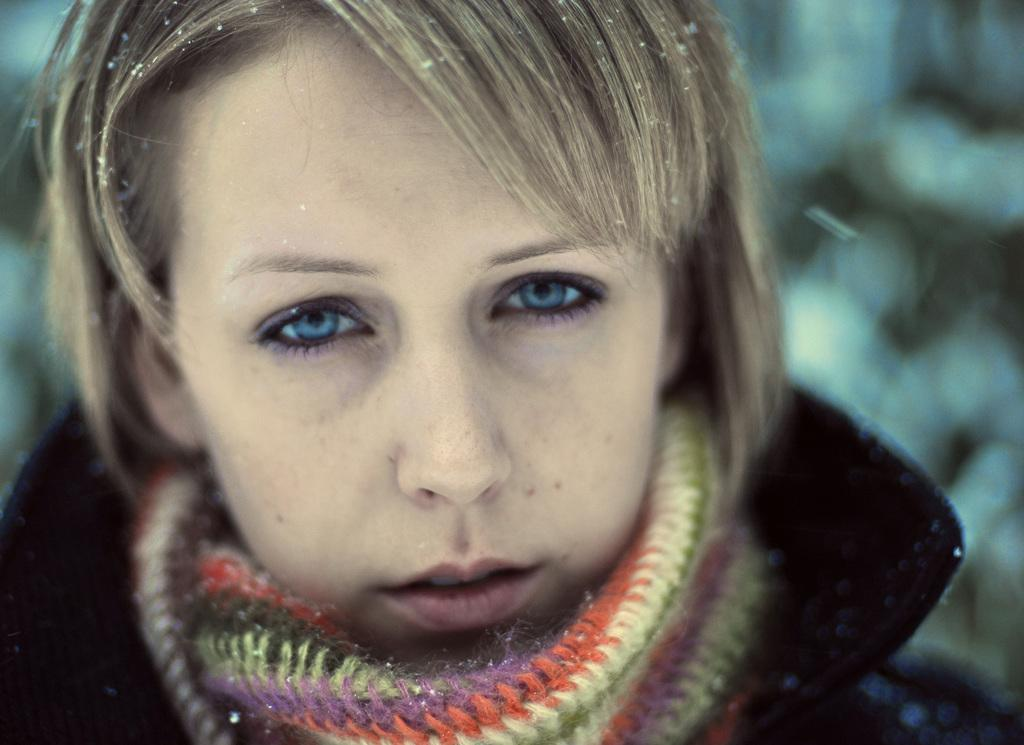Who is the main subject in the image? There is a lady in the image. What type of clothing is the lady wearing? The lady is wearing a jacket and a scarf. What type of advertisement is displayed on the tent in the image? There is no tent present in the image, and therefore no advertisement can be observed. Can you describe the owl sitting on the lady's shoulder in the image? There is no owl present in the image; the lady is only wearing a jacket and a scarf. 